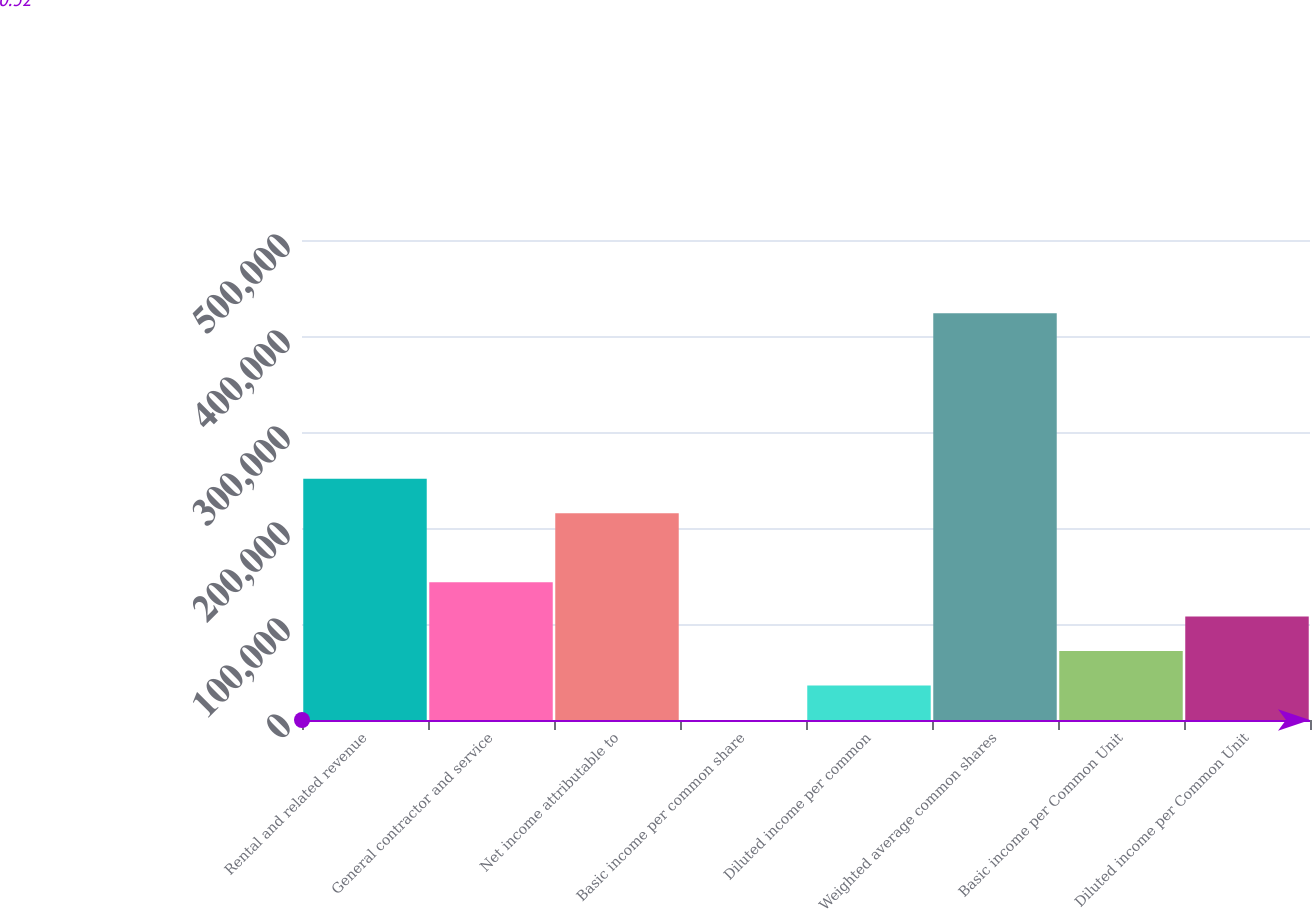<chart> <loc_0><loc_0><loc_500><loc_500><bar_chart><fcel>Rental and related revenue<fcel>General contractor and service<fcel>Net income attributable to<fcel>Basic income per common share<fcel>Diluted income per common<fcel>Weighted average common shares<fcel>Basic income per Common Unit<fcel>Diluted income per Common Unit<nl><fcel>251287<fcel>143593<fcel>215389<fcel>0.32<fcel>35898.4<fcel>423652<fcel>71796.5<fcel>107695<nl></chart> 